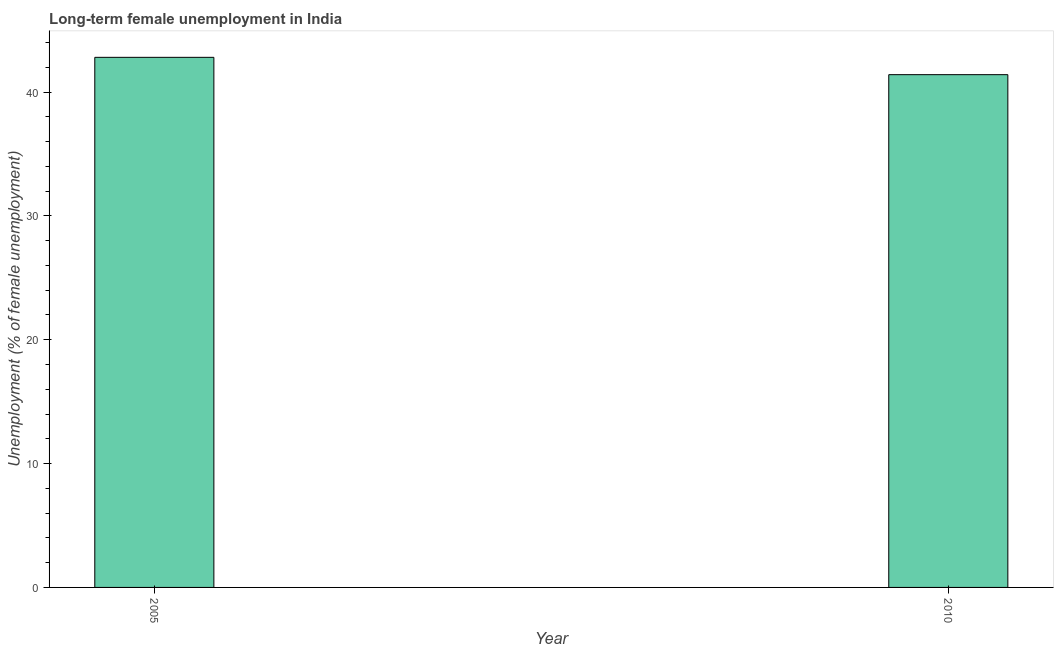What is the title of the graph?
Ensure brevity in your answer.  Long-term female unemployment in India. What is the label or title of the Y-axis?
Give a very brief answer. Unemployment (% of female unemployment). What is the long-term female unemployment in 2005?
Offer a terse response. 42.8. Across all years, what is the maximum long-term female unemployment?
Your answer should be compact. 42.8. Across all years, what is the minimum long-term female unemployment?
Offer a terse response. 41.4. In which year was the long-term female unemployment maximum?
Your answer should be very brief. 2005. In which year was the long-term female unemployment minimum?
Make the answer very short. 2010. What is the sum of the long-term female unemployment?
Ensure brevity in your answer.  84.2. What is the average long-term female unemployment per year?
Make the answer very short. 42.1. What is the median long-term female unemployment?
Provide a succinct answer. 42.1. In how many years, is the long-term female unemployment greater than 26 %?
Ensure brevity in your answer.  2. What is the ratio of the long-term female unemployment in 2005 to that in 2010?
Give a very brief answer. 1.03. What is the difference between two consecutive major ticks on the Y-axis?
Your response must be concise. 10. Are the values on the major ticks of Y-axis written in scientific E-notation?
Give a very brief answer. No. What is the Unemployment (% of female unemployment) of 2005?
Ensure brevity in your answer.  42.8. What is the Unemployment (% of female unemployment) of 2010?
Your answer should be very brief. 41.4. What is the ratio of the Unemployment (% of female unemployment) in 2005 to that in 2010?
Provide a succinct answer. 1.03. 